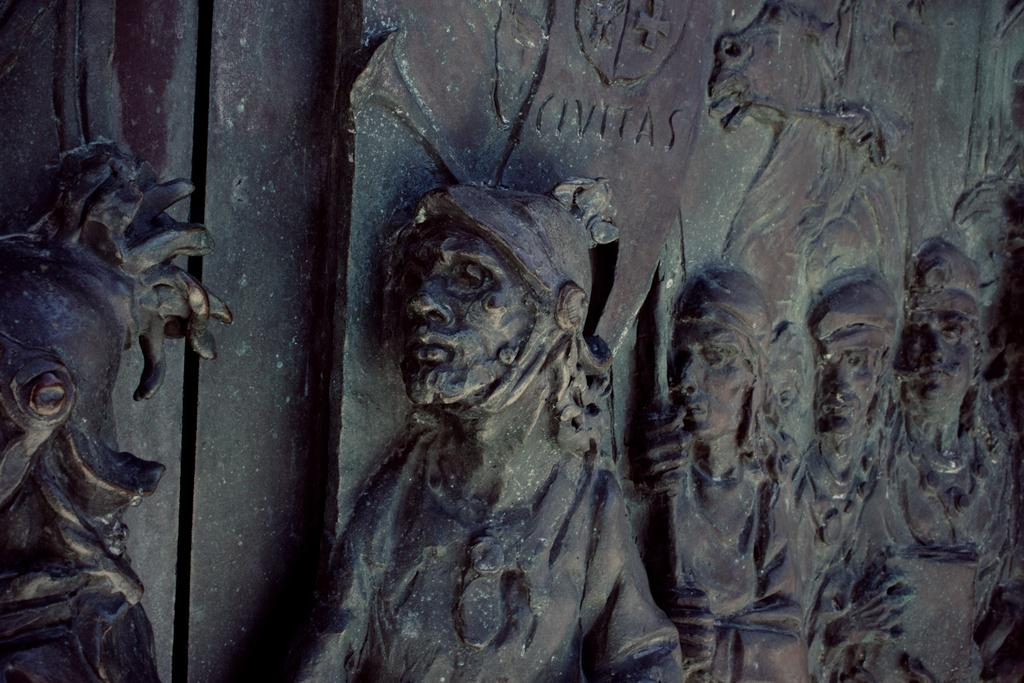What is present on the wall in the image? The wall has human sculptures on it. Can you describe the sculptures on the wall? The sculptures are of human figures. What type of trousers are the sculptures wearing in the image? There is no information about the sculptures' clothing in the image, so it cannot be determined if they are wearing trousers. 